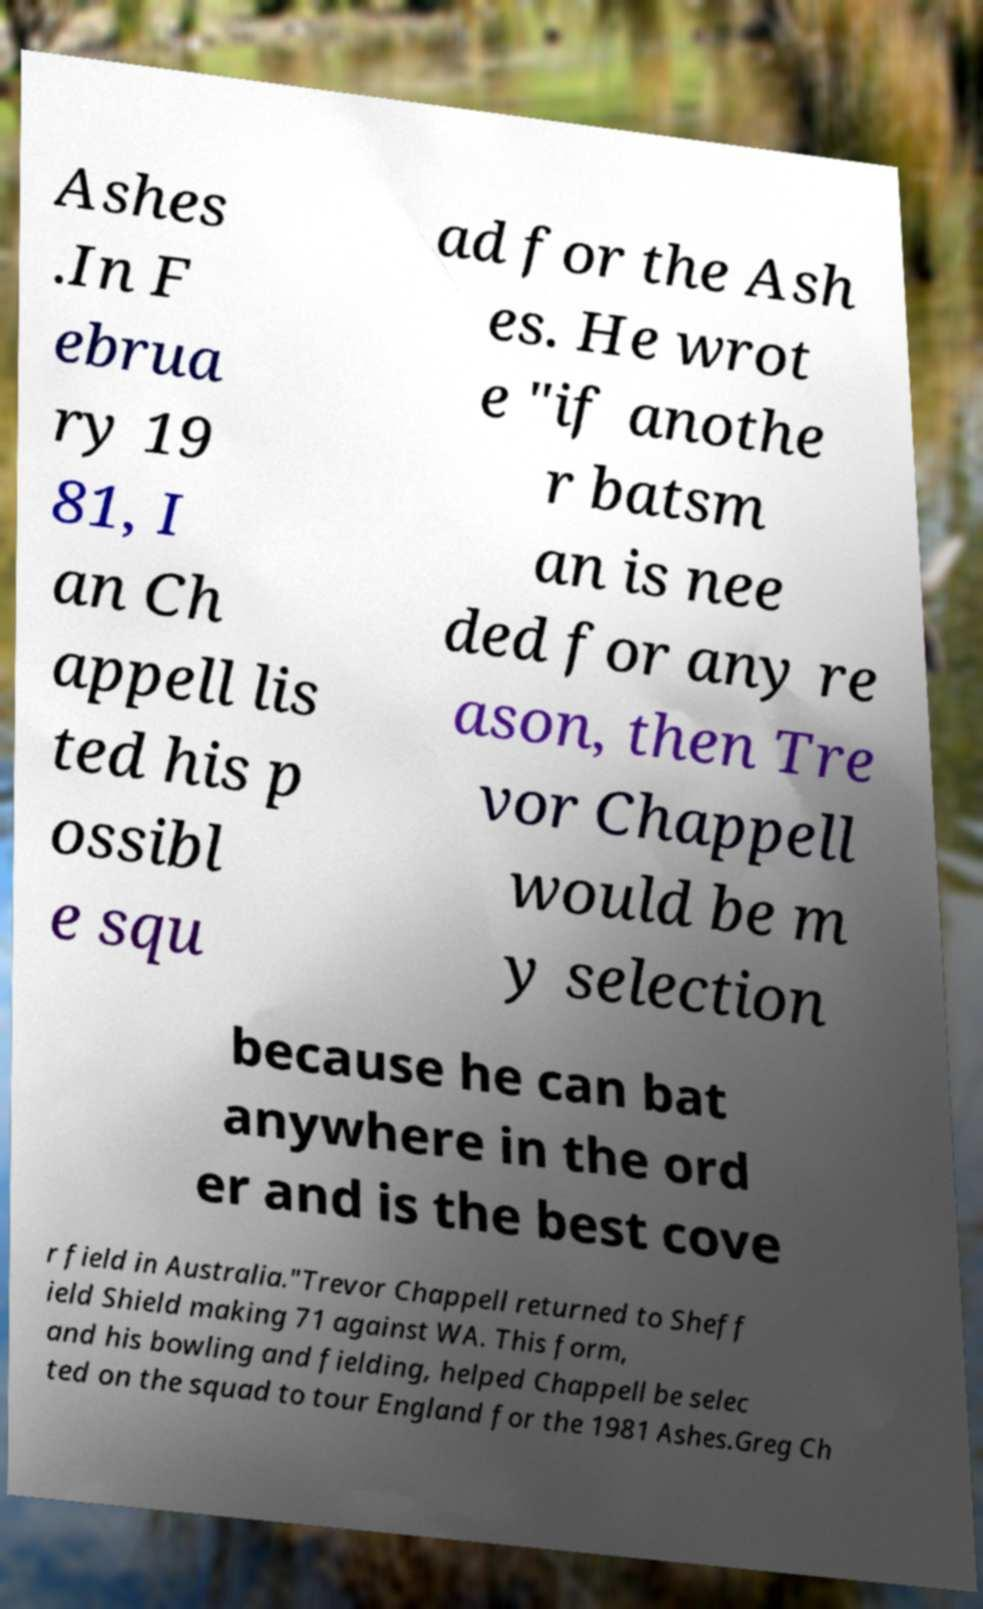Could you assist in decoding the text presented in this image and type it out clearly? Ashes .In F ebrua ry 19 81, I an Ch appell lis ted his p ossibl e squ ad for the Ash es. He wrot e "if anothe r batsm an is nee ded for any re ason, then Tre vor Chappell would be m y selection because he can bat anywhere in the ord er and is the best cove r field in Australia."Trevor Chappell returned to Sheff ield Shield making 71 against WA. This form, and his bowling and fielding, helped Chappell be selec ted on the squad to tour England for the 1981 Ashes.Greg Ch 